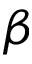Convert formula to latex. <formula><loc_0><loc_0><loc_500><loc_500>\beta</formula> 